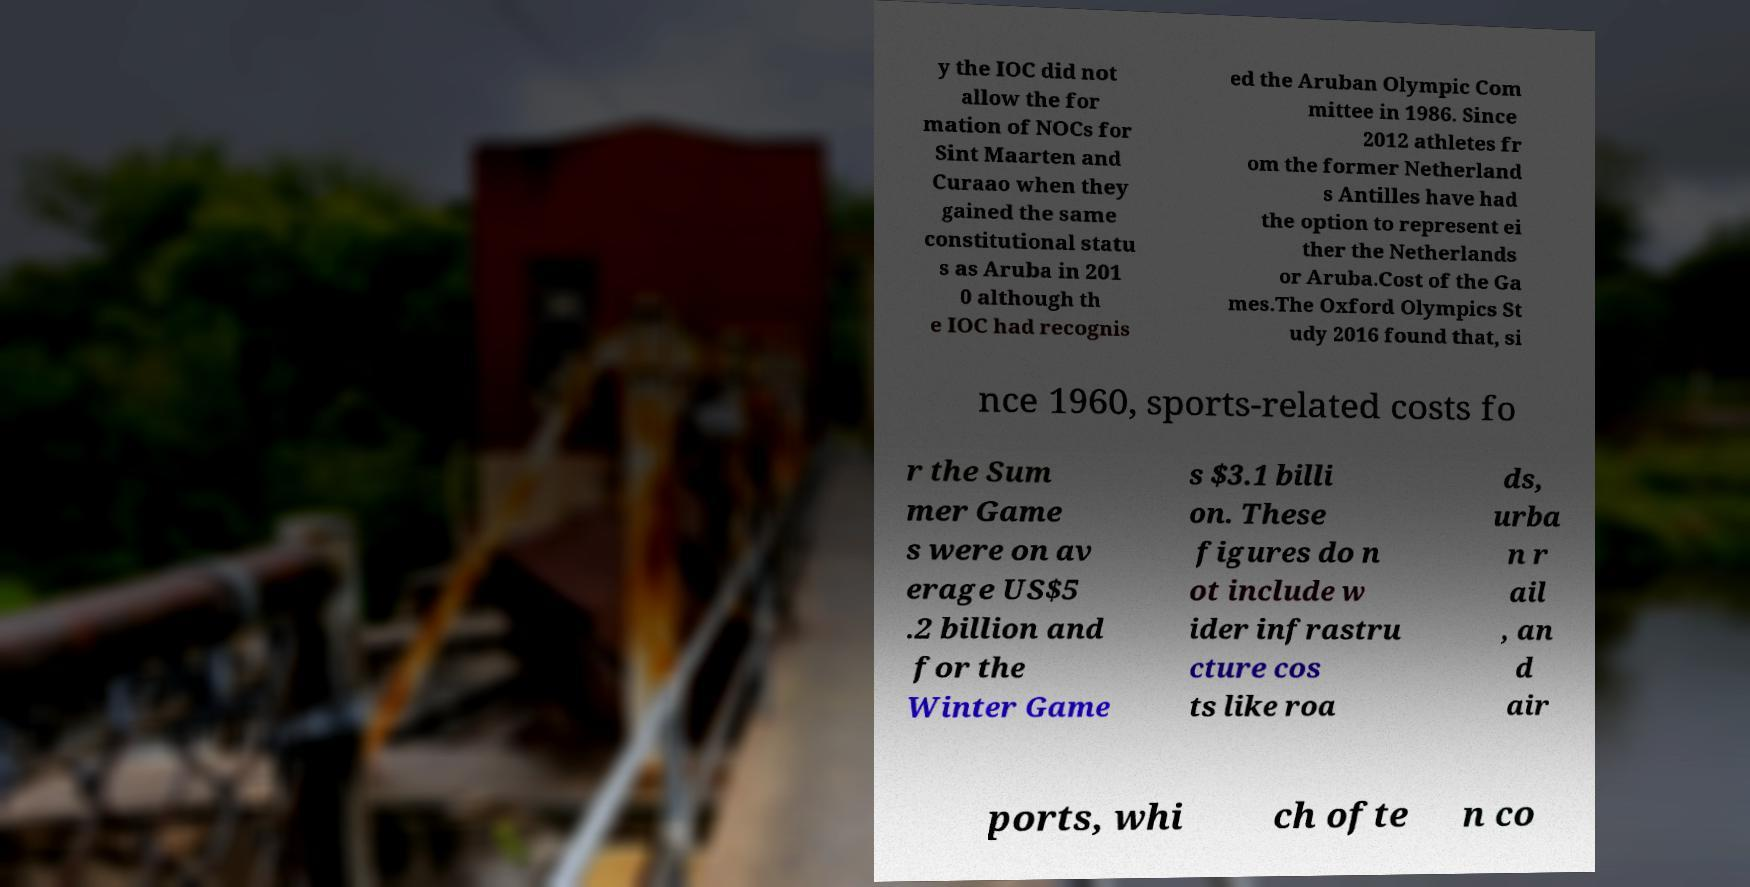What messages or text are displayed in this image? I need them in a readable, typed format. y the IOC did not allow the for mation of NOCs for Sint Maarten and Curaao when they gained the same constitutional statu s as Aruba in 201 0 although th e IOC had recognis ed the Aruban Olympic Com mittee in 1986. Since 2012 athletes fr om the former Netherland s Antilles have had the option to represent ei ther the Netherlands or Aruba.Cost of the Ga mes.The Oxford Olympics St udy 2016 found that, si nce 1960, sports-related costs fo r the Sum mer Game s were on av erage US$5 .2 billion and for the Winter Game s $3.1 billi on. These figures do n ot include w ider infrastru cture cos ts like roa ds, urba n r ail , an d air ports, whi ch ofte n co 